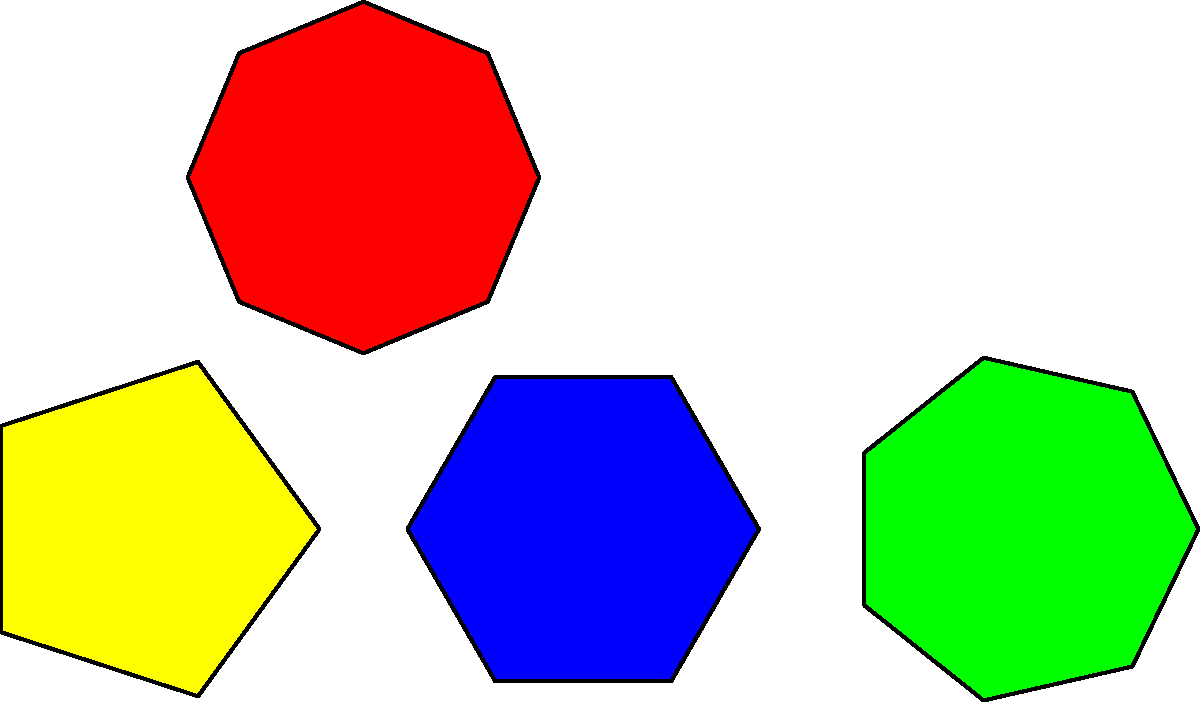As a shopkeeper who respects law enforcement, you often notice different police badges. In the image above, which badge shape is most commonly associated with the highest-ranking police officers in our region? To answer this question, we need to analyze the different badge shapes presented and relate them to our local police hierarchy:

1. The image shows four different badge shapes:
   a) A 5-pointed star (yellow)
   b) A 6-pointed star (blue)
   c) A 7-pointed star (green)
   d) An 8-pointed star (red)

2. In our region, the police badge system typically follows this pattern:
   - Lower-ranking officers often have simpler designs with fewer points
   - Higher-ranking officers usually have more complex designs with more points

3. The 8-pointed star (red badge) is the most complex shape in the image

4. In Lakki Marwat and surrounding areas, the highest-ranking police officers, such as the District Police Officer (DPO) or higher, often wear badges with 8 points

5. The other shapes are typically associated with lower ranks:
   - 5-pointed star: Often used for constables or junior officers
   - 6-pointed star: Commonly seen for mid-level officers
   - 7-pointed star: Usually for senior officers, but not the highest rank

Therefore, based on our local police insignia system, the 8-pointed star (red badge) is most likely associated with the highest-ranking police officers in our region.
Answer: 8-pointed star (red badge) 